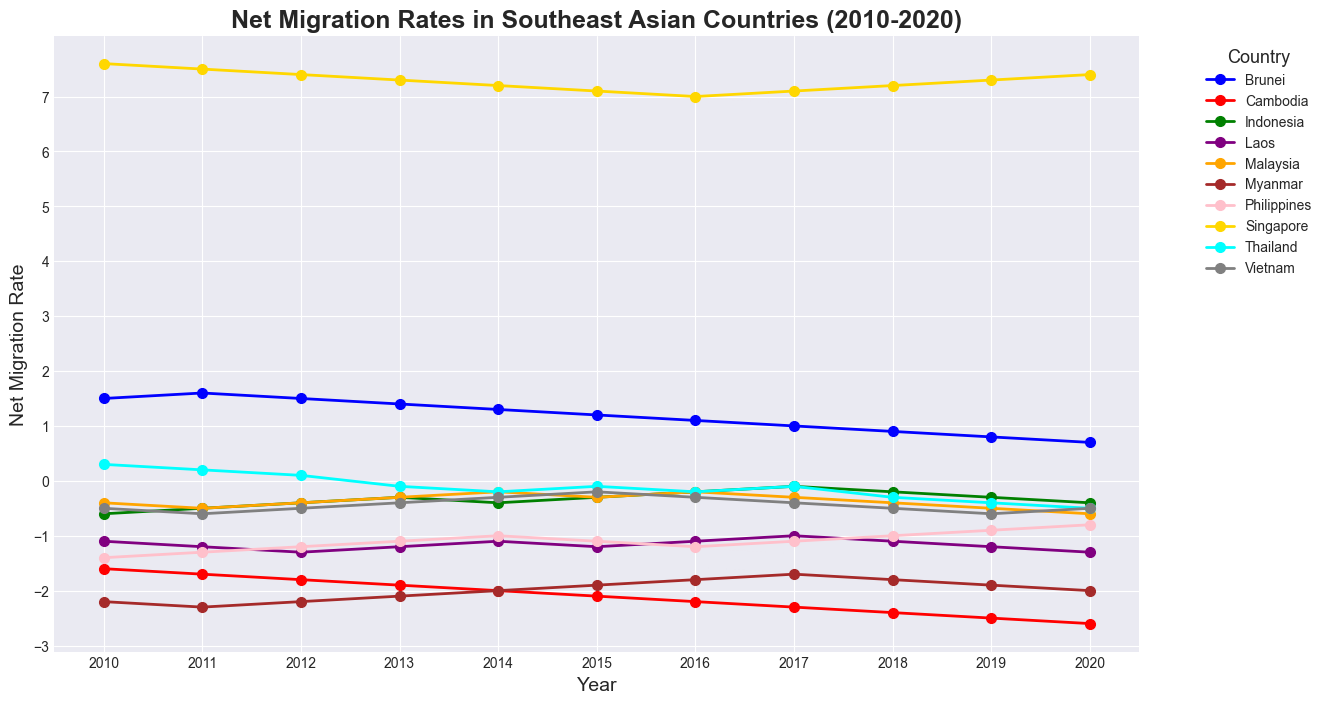Which country consistently had the highest net migration rate from 2010 to 2020? Looking at the plot, Singapore had the highest net migration rate across all the years from 2010 to 2020, marked by its gold-colored line persistently being at the top.
Answer: Singapore Was there any country that had a positive net migration rate in every year? Brunei and Singapore are the only countries with consistently positive net migration rates from 2010 to 2020, visible by their lines remaining above zero.
Answer: Brunei and Singapore Which country experienced the largest decrease in net migration rate over the decade? Cambodia experienced the largest decrease, dropping from -1.6 in 2010 to -2.6 in 2020, indicating a total decrease of -1.0.
Answer: Cambodia Compare the net migration rate of Malaysia and Vietnam in 2015. Which was higher? In 2015, Malaysia's net migration rate was -0.3, while Vietnam's was -0.2. So, Vietnam's net migration rate was higher.
Answer: Vietnam Did any country show an increasing trend in net migration rate over the decade? The Philippines showed an increasing trend, moving from -1.4 in 2010 to -0.8 in 2020, as evidenced by the ascending pink line over the years.
Answer: The Philippines Which countries had a net migration rate below -1.0 throughout the entire decade? Cambodia, Laos, and Myanmar had net migration rates below -1.0 every year from 2010 to 2020. Their lines remained consistently below the -1.0 mark in the plot.
Answer: Cambodia, Laos, and Myanmar Between 2016 and 2017, which country showed the most improvement in net migration rate? Myanmar showed the most improvement between 2016 and 2017, with its net migration rate increasing from -1.8 to -1.7, visible by the upward trend in the brown line.
Answer: Myanmar Did any country have a net migration rate of exactly zero at any point in the decade? No country had a net migration rate of exactly zero at any point; all lines stayed above or below the zero mark throughout the decade.
Answer: No Which country had the lowest net migration rate in 2020? Cambodia had the lowest net migration rate in 2020 at -2.6, depicted by the lowest point of the red line in that year.
Answer: Cambodia 